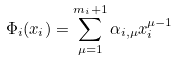Convert formula to latex. <formula><loc_0><loc_0><loc_500><loc_500>\Phi _ { i } ( x _ { i } ) = \sum _ { \mu = 1 } ^ { m _ { i } + 1 } \alpha _ { i , \mu } x _ { i } ^ { \mu - 1 }</formula> 